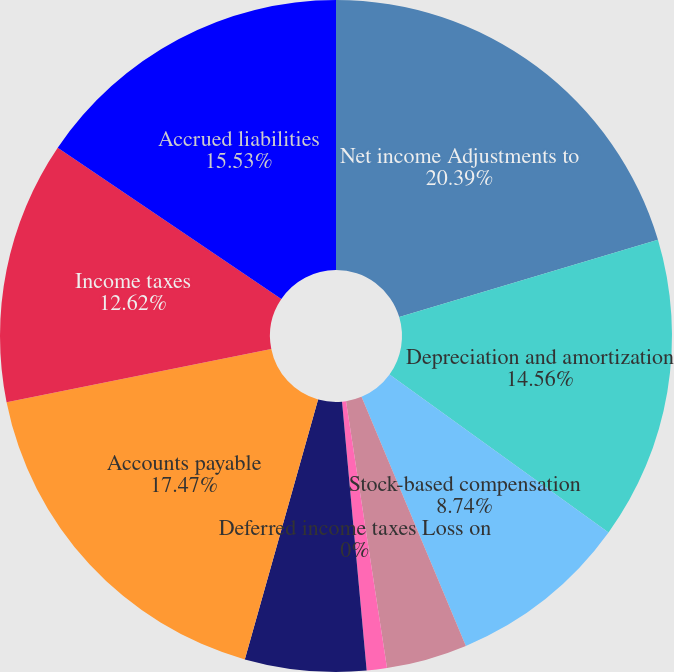Convert chart to OTSL. <chart><loc_0><loc_0><loc_500><loc_500><pie_chart><fcel>Net income Adjustments to<fcel>Depreciation and amortization<fcel>Stock-based compensation<fcel>Provision for doubtful<fcel>Pension expense (less than) in<fcel>Deferred income taxes Loss on<fcel>Other net Changes in operating<fcel>Accounts payable<fcel>Income taxes<fcel>Accrued liabilities<nl><fcel>20.38%<fcel>14.56%<fcel>8.74%<fcel>3.89%<fcel>0.97%<fcel>0.0%<fcel>5.83%<fcel>17.47%<fcel>12.62%<fcel>15.53%<nl></chart> 